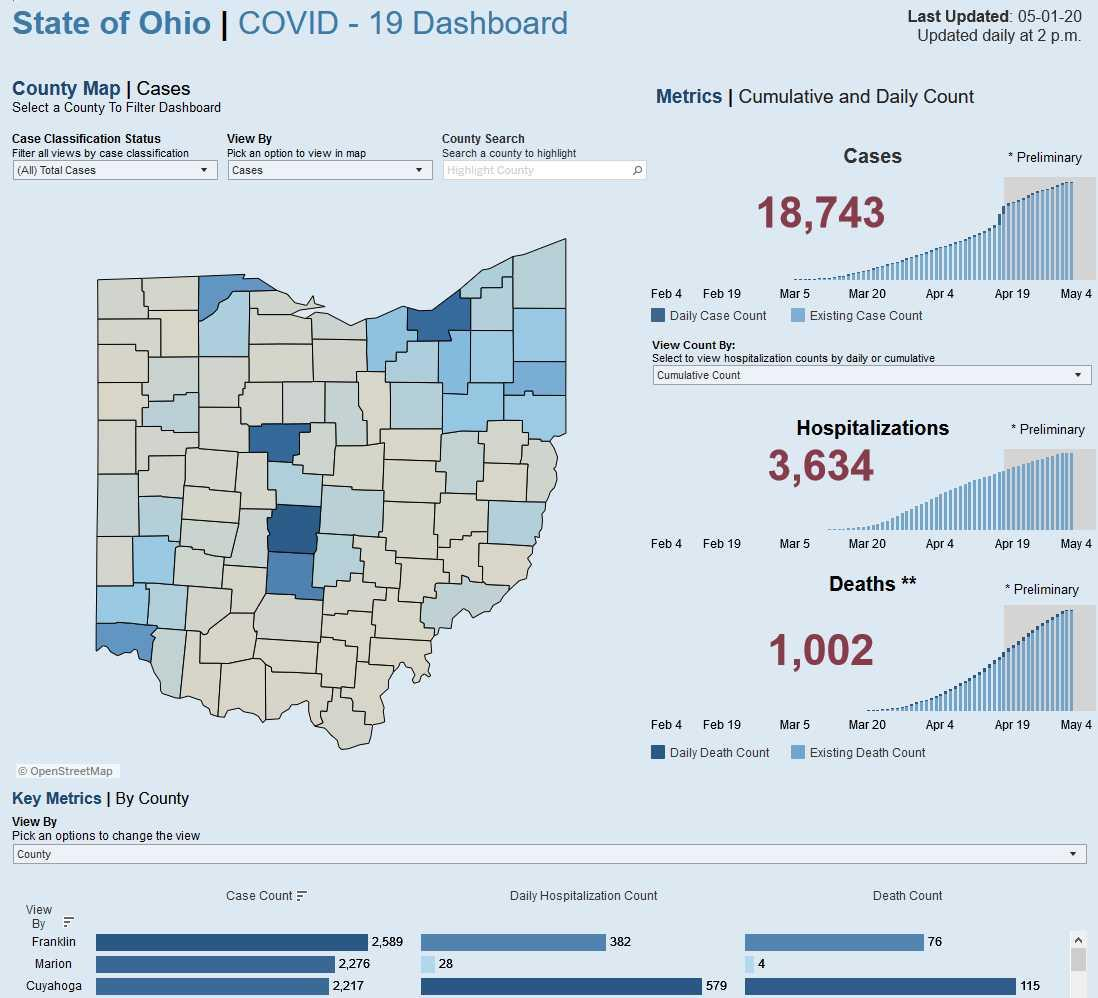Give some essential details in this illustration. Cuyahoga County has the highest death count among all counties in the region. According to the provided data, there were 1,002 deaths in total. The death count in Cuyahoga County is higher than Franklin County by 39. In Marion County, there has been a death toll of 4. Cuyahoga County has the highest daily hospitalization count among all counties in the United States. 